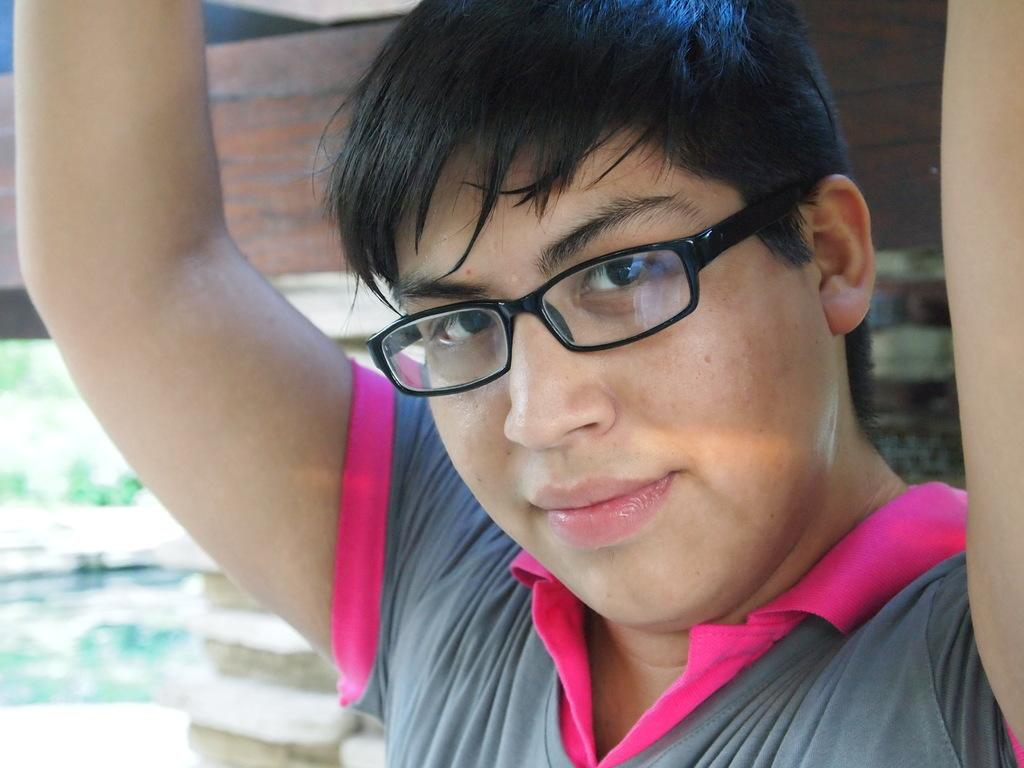What can be seen in the image? There is a person in the image. What is the person wearing? The person is wearing spectacles. Can you describe the background of the image? The background of the image is blurry. What type of yak can be seen in the front of the image? There is no yak present in the image; it features a person wearing spectacles with a blurry background. 